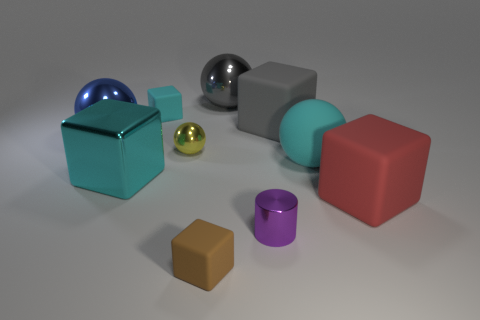Subtract 1 spheres. How many spheres are left? 3 Subtract all brown cubes. How many cubes are left? 4 Subtract all purple cubes. Subtract all gray cylinders. How many cubes are left? 5 Subtract all balls. How many objects are left? 6 Subtract 0 yellow blocks. How many objects are left? 10 Subtract all purple cylinders. Subtract all cyan matte cylinders. How many objects are left? 9 Add 1 large blocks. How many large blocks are left? 4 Add 7 gray spheres. How many gray spheres exist? 8 